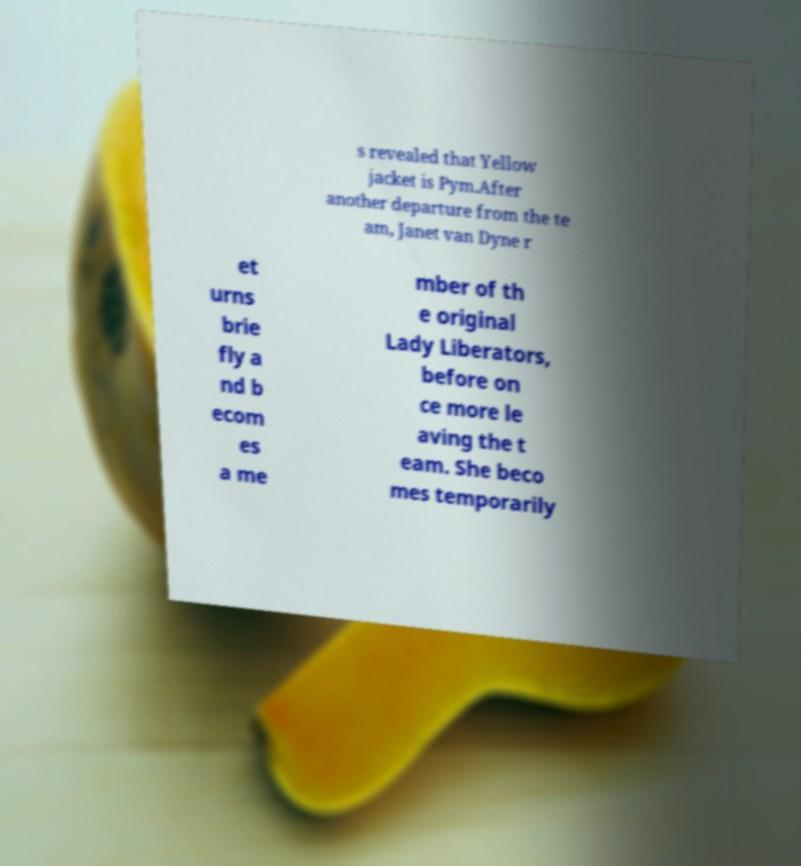Please identify and transcribe the text found in this image. s revealed that Yellow jacket is Pym.After another departure from the te am, Janet van Dyne r et urns brie fly a nd b ecom es a me mber of th e original Lady Liberators, before on ce more le aving the t eam. She beco mes temporarily 